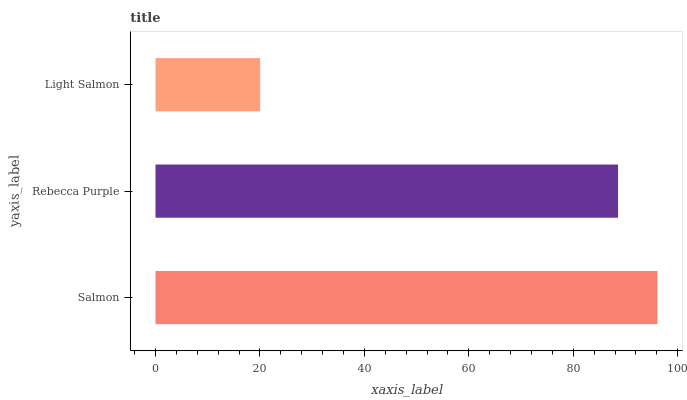Is Light Salmon the minimum?
Answer yes or no. Yes. Is Salmon the maximum?
Answer yes or no. Yes. Is Rebecca Purple the minimum?
Answer yes or no. No. Is Rebecca Purple the maximum?
Answer yes or no. No. Is Salmon greater than Rebecca Purple?
Answer yes or no. Yes. Is Rebecca Purple less than Salmon?
Answer yes or no. Yes. Is Rebecca Purple greater than Salmon?
Answer yes or no. No. Is Salmon less than Rebecca Purple?
Answer yes or no. No. Is Rebecca Purple the high median?
Answer yes or no. Yes. Is Rebecca Purple the low median?
Answer yes or no. Yes. Is Light Salmon the high median?
Answer yes or no. No. Is Salmon the low median?
Answer yes or no. No. 